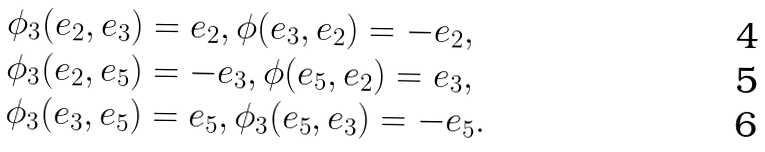<formula> <loc_0><loc_0><loc_500><loc_500>& \phi _ { 3 } ( e _ { 2 } , e _ { 3 } ) = e _ { 2 } , \phi ( e _ { 3 } , e _ { 2 } ) = - e _ { 2 } , \\ & \phi _ { 3 } ( e _ { 2 } , e _ { 5 } ) = - e _ { 3 } , \phi ( e _ { 5 } , e _ { 2 } ) = e _ { 3 } , \\ & \phi _ { 3 } ( e _ { 3 } , e _ { 5 } ) = e _ { 5 } , \phi _ { 3 } ( e _ { 5 } , e _ { 3 } ) = - e _ { 5 } .</formula> 